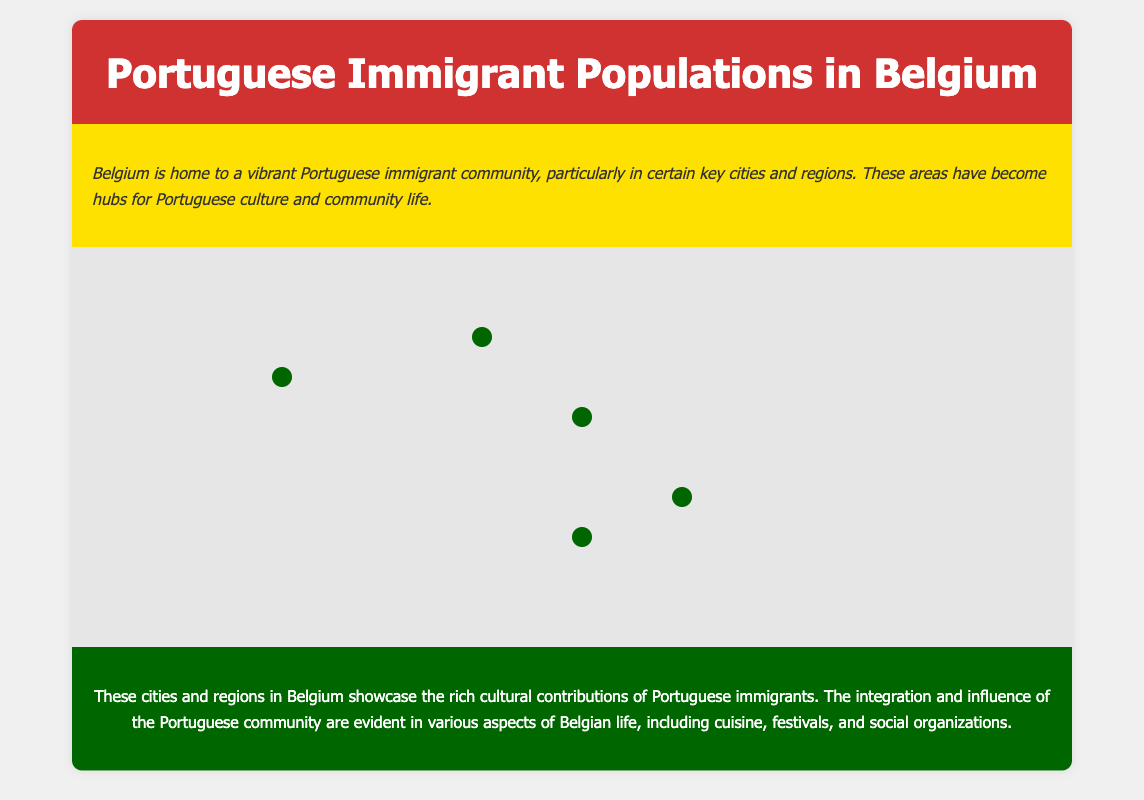What are the notable neighborhoods for the Portuguese community in Brussels? The document states that Saint-Gilles and Ixelles are particularly notable for their Portuguese populations.
Answer: Saint-Gilles and Ixelles Which city in Belgium is known for its diamond district? The document mentions Antwerp as the second-largest city known for its diamond district.
Answer: Antwerp What significant festival in Liège features Portuguese music and food? The document highlights the Fêtes de Wallonie festival in Liège that features Portuguese music and food stalls.
Answer: Fêtes de Wallonie In which city do Portuguese social clubs play a significant role? The document indicates that Portuguese social clubs and associations play a significant role in community life in Charleroi.
Answer: Charleroi Which city has a smaller yet significant Portuguese community? According to the document, Bruges has a smaller yet significant Portuguese community.
Answer: Bruges What is a notable aspect of Portuguese influence in Antwerp? The document states that Portuguese influence is visible in local markets and restaurants, particularly around the Central Station.
Answer: Local markets and restaurants Which neighborhood in Brussels is known for Portuguese bakeries? The document mentions that Saint-Gilles is known for Portuguese bakeries.
Answer: Saint-Gilles What element of Portuguese culture is present in Liège's dynamic scene? The document notes that the Fêtes de Wallonie festival often features Portuguese music and food stalls.
Answer: Music and food stalls What role do Portuguese immigrants have in the tourism industry in Bruges? The document states that the tourism industry offers employment opportunities for immigrants, including the Portuguese.
Answer: Employment opportunities 